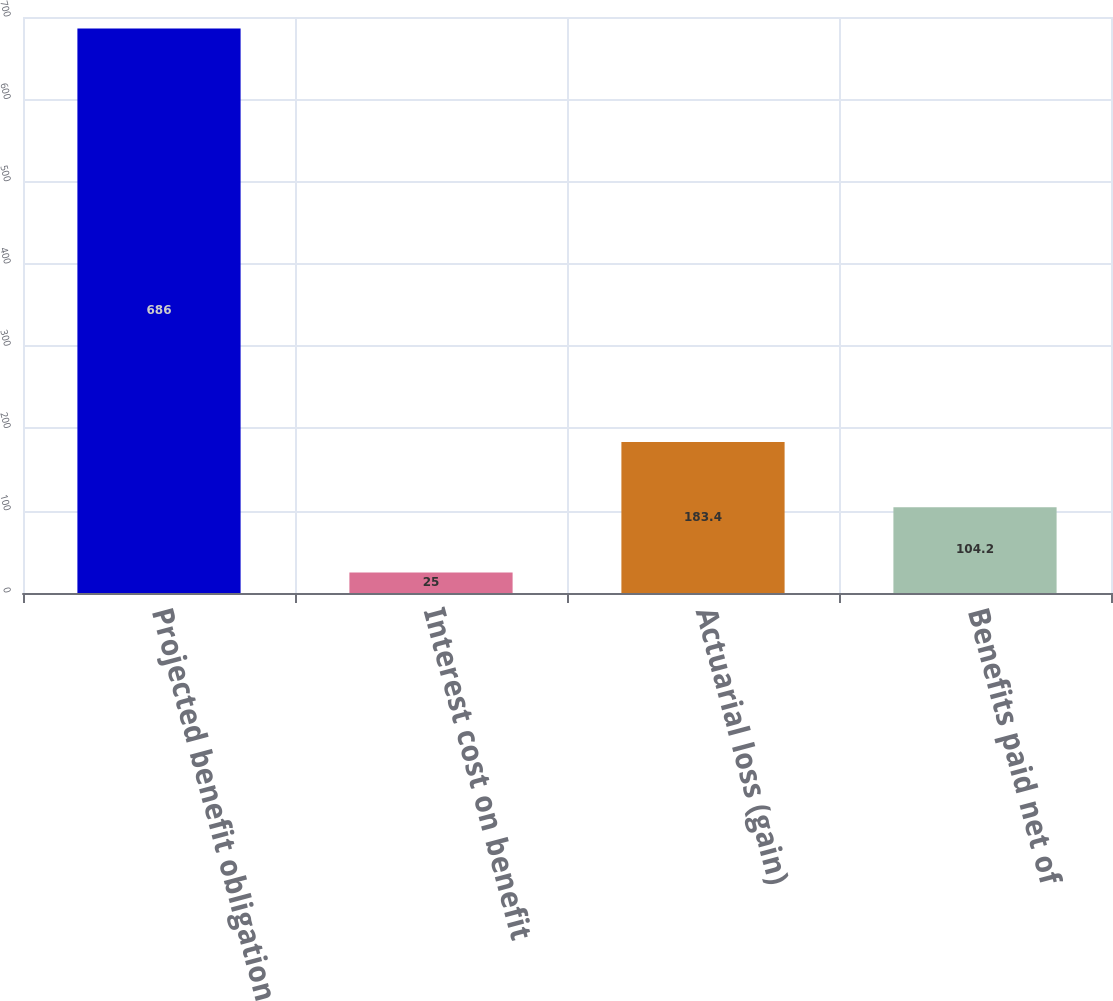Convert chart to OTSL. <chart><loc_0><loc_0><loc_500><loc_500><bar_chart><fcel>Projected benefit obligation<fcel>Interest cost on benefit<fcel>Actuarial loss (gain)<fcel>Benefits paid net of<nl><fcel>686<fcel>25<fcel>183.4<fcel>104.2<nl></chart> 